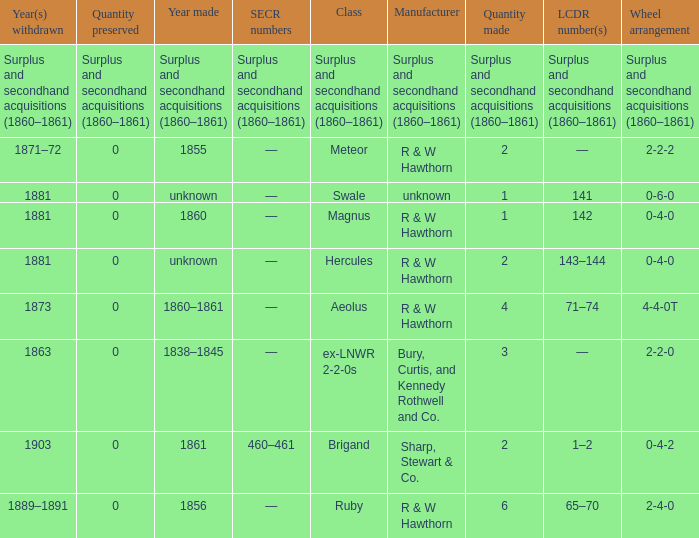What was the SECR number of the item made in 1861? 460–461. 